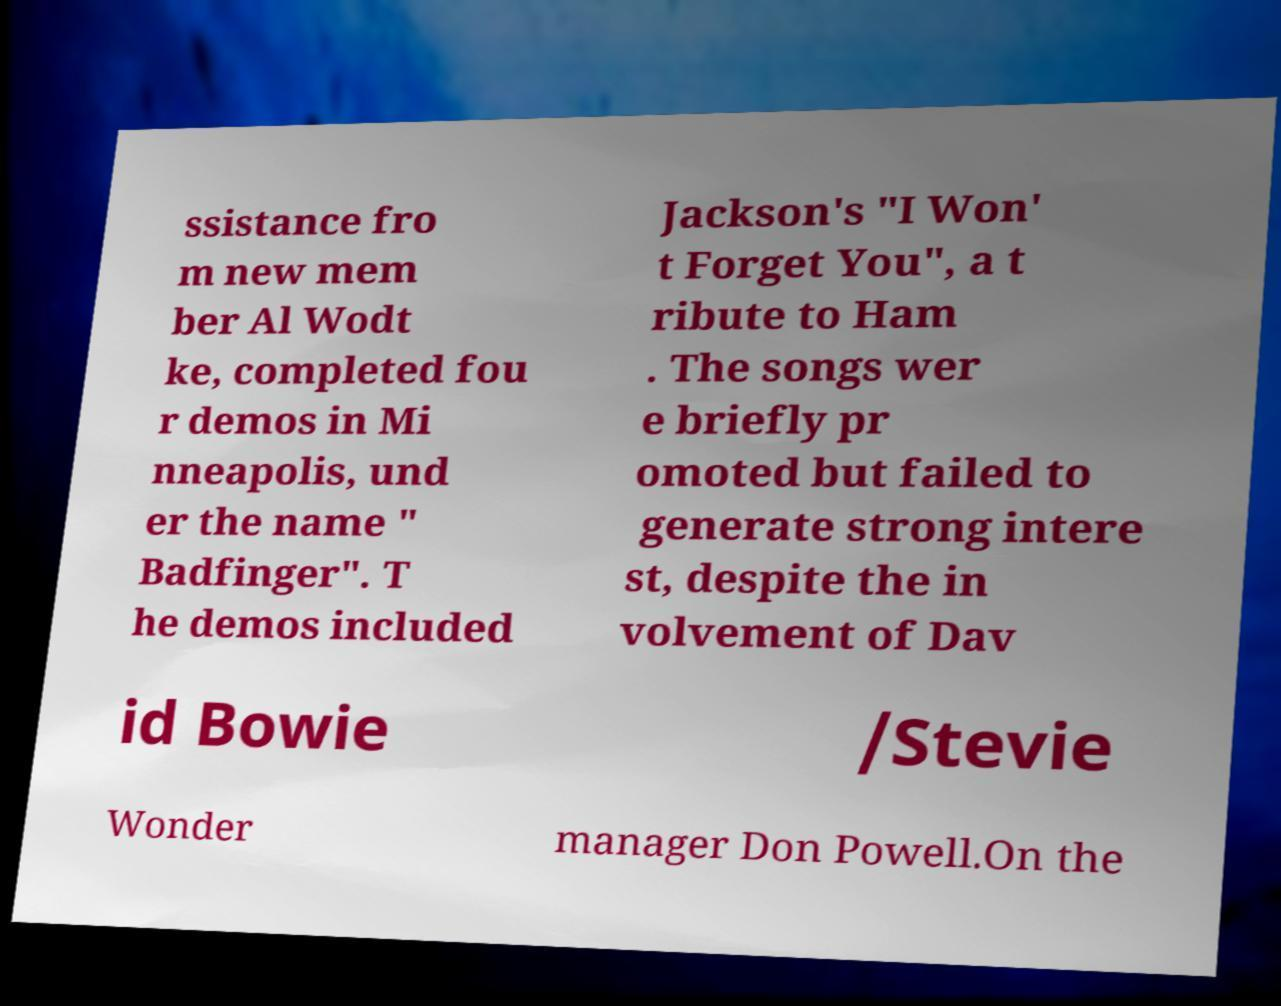For documentation purposes, I need the text within this image transcribed. Could you provide that? ssistance fro m new mem ber Al Wodt ke, completed fou r demos in Mi nneapolis, und er the name " Badfinger". T he demos included Jackson's "I Won' t Forget You", a t ribute to Ham . The songs wer e briefly pr omoted but failed to generate strong intere st, despite the in volvement of Dav id Bowie /Stevie Wonder manager Don Powell.On the 